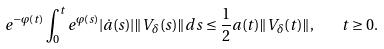Convert formula to latex. <formula><loc_0><loc_0><loc_500><loc_500>e ^ { - \varphi ( t ) } \int _ { 0 } ^ { t } e ^ { \varphi ( s ) } | \dot { a } ( s ) | \| V _ { \delta } ( s ) \| d s \leq \frac { 1 } { 2 } a ( t ) \| V _ { \delta } ( t ) \| , \quad t \geq 0 .</formula> 